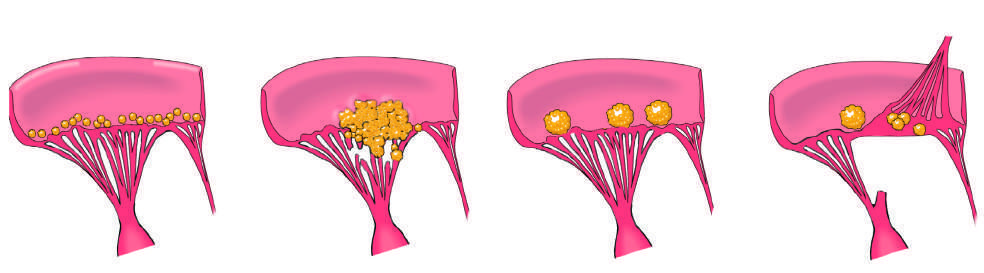what is infective endocarditis characterized by that can extend from valve leaflets onto adjacent structures e.g., chordae or myocardium?
Answer the question using a single word or phrase. Large 